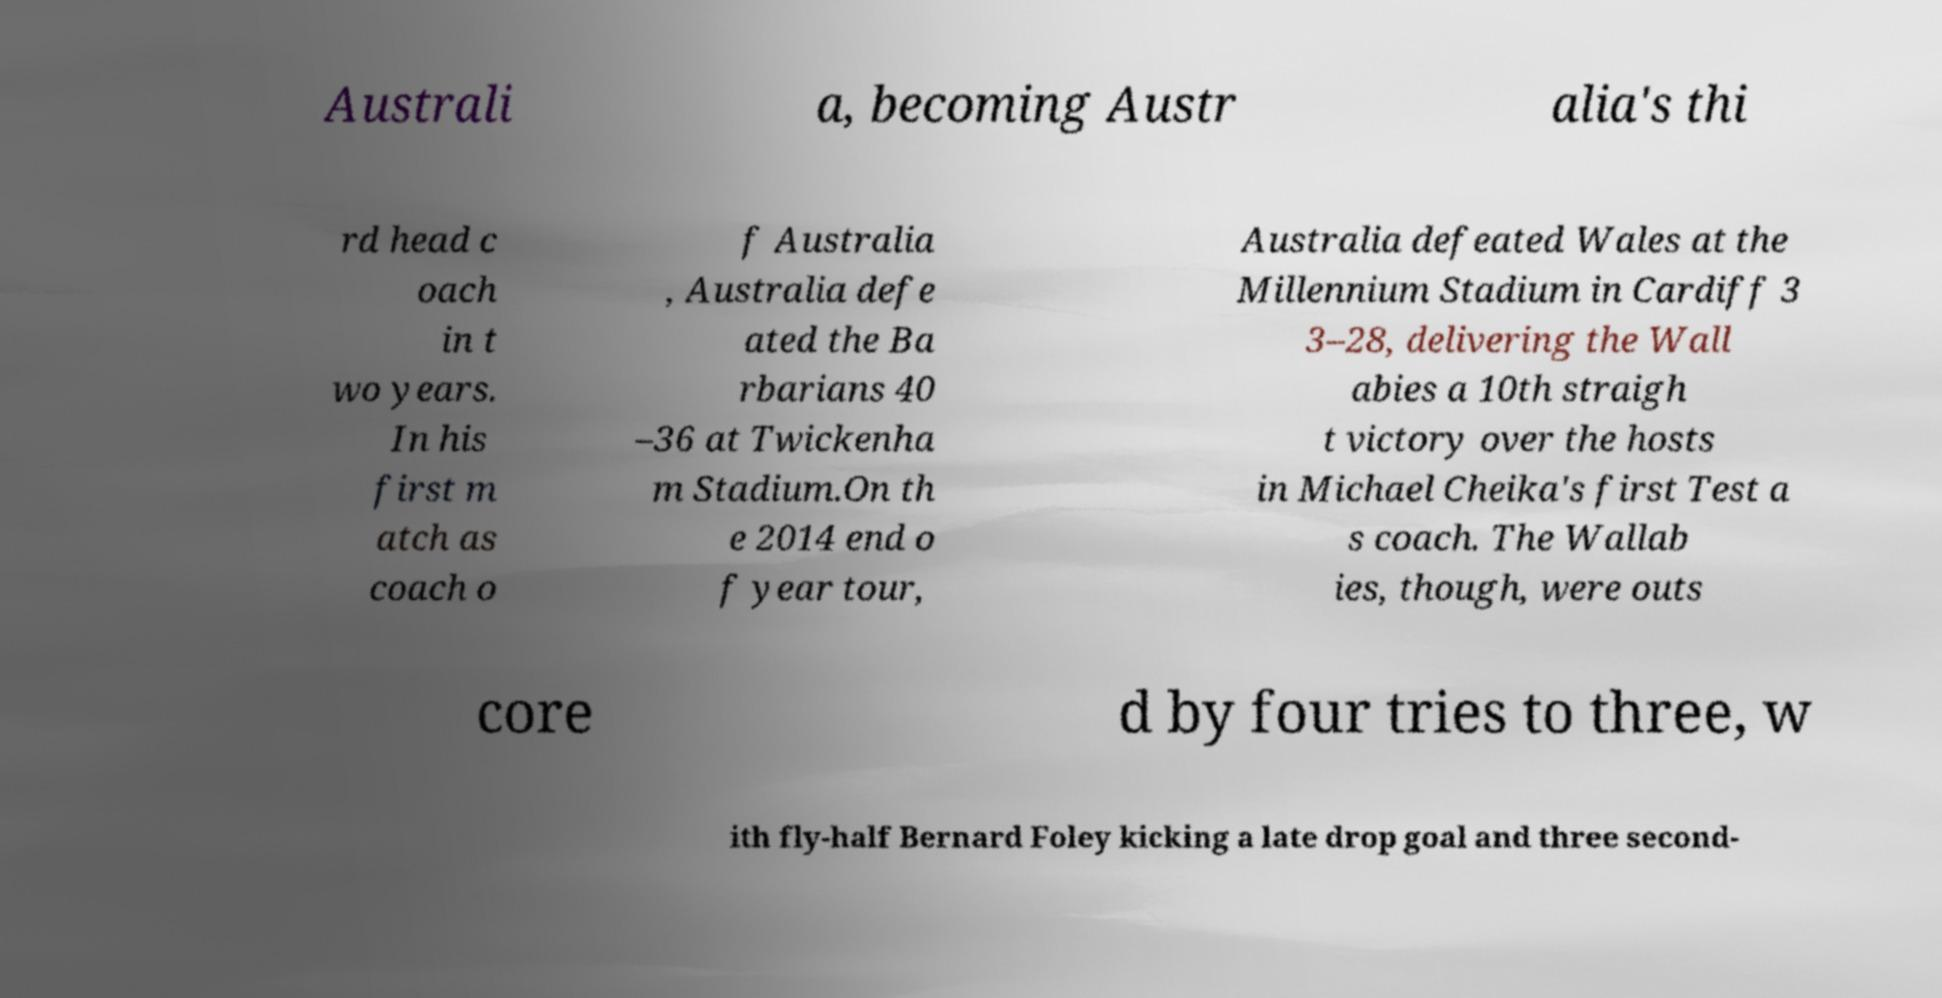There's text embedded in this image that I need extracted. Can you transcribe it verbatim? Australi a, becoming Austr alia's thi rd head c oach in t wo years. In his first m atch as coach o f Australia , Australia defe ated the Ba rbarians 40 –36 at Twickenha m Stadium.On th e 2014 end o f year tour, Australia defeated Wales at the Millennium Stadium in Cardiff 3 3–28, delivering the Wall abies a 10th straigh t victory over the hosts in Michael Cheika's first Test a s coach. The Wallab ies, though, were outs core d by four tries to three, w ith fly-half Bernard Foley kicking a late drop goal and three second- 